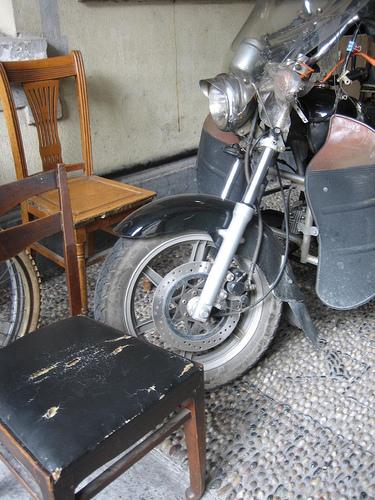What is the name of the brown chair's style?
Answer briefly. Mission. How many tires do you see?
Keep it brief. 2. How many chairs have a cushion?
Be succinct. 1. 